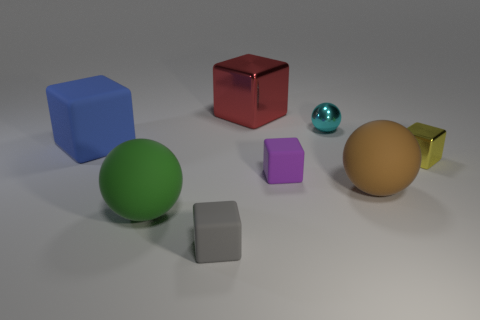What number of other things are there of the same material as the green ball
Make the answer very short. 4. Are there any tiny yellow metallic objects behind the brown ball?
Provide a short and direct response. Yes. There is a purple rubber cube; is its size the same as the matte cube behind the small yellow metal object?
Your answer should be very brief. No. There is a large rubber ball that is left of the shiny object behind the small cyan metallic thing; what is its color?
Provide a short and direct response. Green. Do the gray rubber block and the brown matte object have the same size?
Keep it short and to the point. No. There is a large matte object that is in front of the purple thing and left of the tiny cyan metal sphere; what color is it?
Give a very brief answer. Green. What is the size of the brown matte ball?
Give a very brief answer. Large. Is the color of the block that is on the right side of the brown rubber sphere the same as the large shiny cube?
Keep it short and to the point. No. Is the number of brown rubber things left of the large brown matte thing greater than the number of large shiny things that are in front of the small purple thing?
Provide a succinct answer. No. Are there more purple cubes than large matte cylinders?
Keep it short and to the point. Yes. 